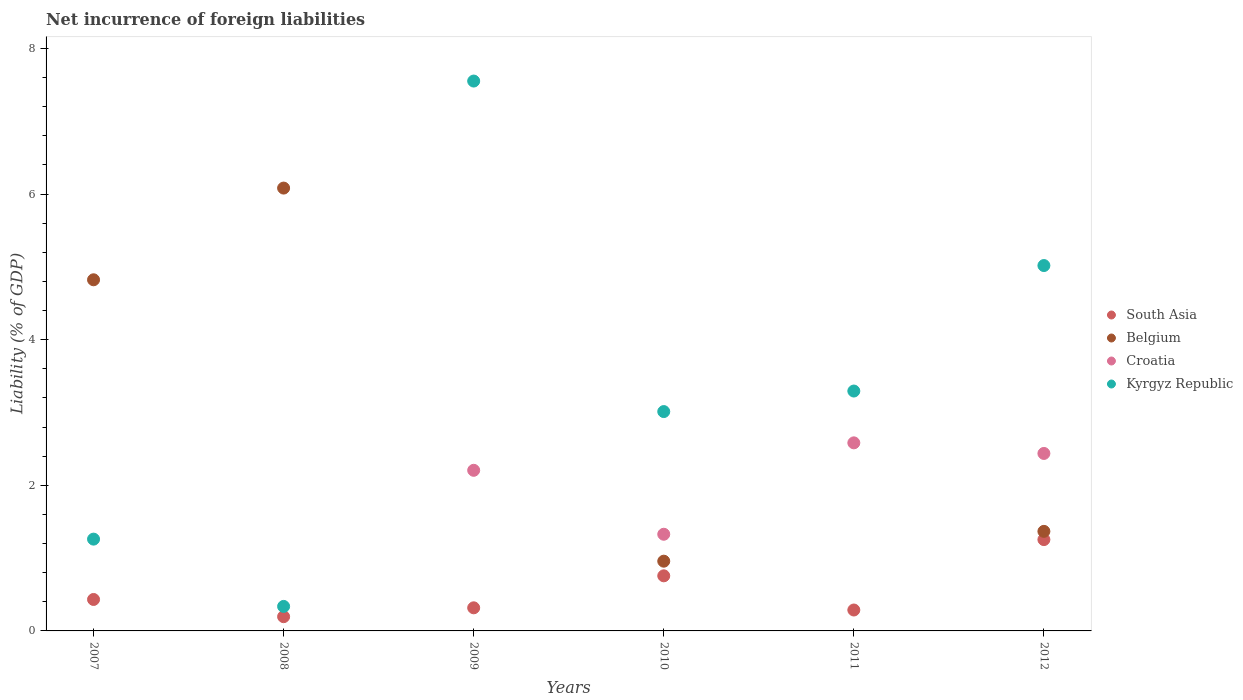How many different coloured dotlines are there?
Your answer should be very brief. 4. What is the net incurrence of foreign liabilities in Kyrgyz Republic in 2009?
Offer a very short reply. 7.55. Across all years, what is the maximum net incurrence of foreign liabilities in Croatia?
Your answer should be very brief. 2.58. Across all years, what is the minimum net incurrence of foreign liabilities in South Asia?
Provide a short and direct response. 0.2. In which year was the net incurrence of foreign liabilities in Kyrgyz Republic maximum?
Your response must be concise. 2009. What is the total net incurrence of foreign liabilities in Croatia in the graph?
Give a very brief answer. 8.56. What is the difference between the net incurrence of foreign liabilities in Croatia in 2011 and that in 2012?
Offer a very short reply. 0.15. What is the average net incurrence of foreign liabilities in South Asia per year?
Offer a very short reply. 0.54. In the year 2010, what is the difference between the net incurrence of foreign liabilities in Croatia and net incurrence of foreign liabilities in South Asia?
Give a very brief answer. 0.57. In how many years, is the net incurrence of foreign liabilities in Kyrgyz Republic greater than 7.6 %?
Make the answer very short. 0. What is the ratio of the net incurrence of foreign liabilities in Kyrgyz Republic in 2007 to that in 2010?
Your answer should be very brief. 0.42. What is the difference between the highest and the second highest net incurrence of foreign liabilities in Belgium?
Make the answer very short. 1.26. What is the difference between the highest and the lowest net incurrence of foreign liabilities in South Asia?
Keep it short and to the point. 1.06. Is the sum of the net incurrence of foreign liabilities in South Asia in 2007 and 2012 greater than the maximum net incurrence of foreign liabilities in Belgium across all years?
Provide a short and direct response. No. Is it the case that in every year, the sum of the net incurrence of foreign liabilities in Belgium and net incurrence of foreign liabilities in South Asia  is greater than the net incurrence of foreign liabilities in Kyrgyz Republic?
Offer a terse response. No. Is the net incurrence of foreign liabilities in Kyrgyz Republic strictly less than the net incurrence of foreign liabilities in Croatia over the years?
Ensure brevity in your answer.  No. What is the difference between two consecutive major ticks on the Y-axis?
Your answer should be compact. 2. Does the graph contain grids?
Your response must be concise. No. How many legend labels are there?
Offer a terse response. 4. What is the title of the graph?
Provide a short and direct response. Net incurrence of foreign liabilities. Does "Eritrea" appear as one of the legend labels in the graph?
Make the answer very short. No. What is the label or title of the X-axis?
Keep it short and to the point. Years. What is the label or title of the Y-axis?
Your answer should be very brief. Liability (% of GDP). What is the Liability (% of GDP) in South Asia in 2007?
Keep it short and to the point. 0.43. What is the Liability (% of GDP) of Belgium in 2007?
Your response must be concise. 4.82. What is the Liability (% of GDP) in Croatia in 2007?
Ensure brevity in your answer.  0. What is the Liability (% of GDP) of Kyrgyz Republic in 2007?
Ensure brevity in your answer.  1.26. What is the Liability (% of GDP) in South Asia in 2008?
Offer a very short reply. 0.2. What is the Liability (% of GDP) in Belgium in 2008?
Provide a short and direct response. 6.08. What is the Liability (% of GDP) in Croatia in 2008?
Provide a succinct answer. 0. What is the Liability (% of GDP) of Kyrgyz Republic in 2008?
Give a very brief answer. 0.34. What is the Liability (% of GDP) of South Asia in 2009?
Offer a terse response. 0.32. What is the Liability (% of GDP) of Belgium in 2009?
Offer a terse response. 0. What is the Liability (% of GDP) of Croatia in 2009?
Provide a short and direct response. 2.21. What is the Liability (% of GDP) in Kyrgyz Republic in 2009?
Give a very brief answer. 7.55. What is the Liability (% of GDP) in South Asia in 2010?
Make the answer very short. 0.76. What is the Liability (% of GDP) of Belgium in 2010?
Offer a very short reply. 0.96. What is the Liability (% of GDP) of Croatia in 2010?
Keep it short and to the point. 1.33. What is the Liability (% of GDP) of Kyrgyz Republic in 2010?
Ensure brevity in your answer.  3.01. What is the Liability (% of GDP) in South Asia in 2011?
Your answer should be very brief. 0.29. What is the Liability (% of GDP) in Belgium in 2011?
Provide a succinct answer. 0. What is the Liability (% of GDP) in Croatia in 2011?
Offer a terse response. 2.58. What is the Liability (% of GDP) of Kyrgyz Republic in 2011?
Offer a very short reply. 3.3. What is the Liability (% of GDP) in South Asia in 2012?
Your answer should be very brief. 1.25. What is the Liability (% of GDP) in Belgium in 2012?
Your answer should be compact. 1.37. What is the Liability (% of GDP) of Croatia in 2012?
Offer a terse response. 2.44. What is the Liability (% of GDP) in Kyrgyz Republic in 2012?
Your response must be concise. 5.02. Across all years, what is the maximum Liability (% of GDP) of South Asia?
Provide a short and direct response. 1.25. Across all years, what is the maximum Liability (% of GDP) of Belgium?
Offer a very short reply. 6.08. Across all years, what is the maximum Liability (% of GDP) of Croatia?
Offer a terse response. 2.58. Across all years, what is the maximum Liability (% of GDP) in Kyrgyz Republic?
Offer a terse response. 7.55. Across all years, what is the minimum Liability (% of GDP) of South Asia?
Your response must be concise. 0.2. Across all years, what is the minimum Liability (% of GDP) of Croatia?
Your response must be concise. 0. Across all years, what is the minimum Liability (% of GDP) in Kyrgyz Republic?
Your answer should be very brief. 0.34. What is the total Liability (% of GDP) of South Asia in the graph?
Keep it short and to the point. 3.24. What is the total Liability (% of GDP) in Belgium in the graph?
Your response must be concise. 13.23. What is the total Liability (% of GDP) of Croatia in the graph?
Your answer should be compact. 8.56. What is the total Liability (% of GDP) of Kyrgyz Republic in the graph?
Your answer should be compact. 20.48. What is the difference between the Liability (% of GDP) in South Asia in 2007 and that in 2008?
Offer a terse response. 0.24. What is the difference between the Liability (% of GDP) of Belgium in 2007 and that in 2008?
Provide a succinct answer. -1.26. What is the difference between the Liability (% of GDP) in Kyrgyz Republic in 2007 and that in 2008?
Your answer should be very brief. 0.92. What is the difference between the Liability (% of GDP) of South Asia in 2007 and that in 2009?
Keep it short and to the point. 0.11. What is the difference between the Liability (% of GDP) of Kyrgyz Republic in 2007 and that in 2009?
Keep it short and to the point. -6.29. What is the difference between the Liability (% of GDP) in South Asia in 2007 and that in 2010?
Make the answer very short. -0.32. What is the difference between the Liability (% of GDP) in Belgium in 2007 and that in 2010?
Give a very brief answer. 3.87. What is the difference between the Liability (% of GDP) in Kyrgyz Republic in 2007 and that in 2010?
Your answer should be compact. -1.75. What is the difference between the Liability (% of GDP) of South Asia in 2007 and that in 2011?
Provide a succinct answer. 0.14. What is the difference between the Liability (% of GDP) in Kyrgyz Republic in 2007 and that in 2011?
Keep it short and to the point. -2.03. What is the difference between the Liability (% of GDP) of South Asia in 2007 and that in 2012?
Keep it short and to the point. -0.82. What is the difference between the Liability (% of GDP) in Belgium in 2007 and that in 2012?
Offer a terse response. 3.46. What is the difference between the Liability (% of GDP) of Kyrgyz Republic in 2007 and that in 2012?
Ensure brevity in your answer.  -3.76. What is the difference between the Liability (% of GDP) in South Asia in 2008 and that in 2009?
Your answer should be compact. -0.12. What is the difference between the Liability (% of GDP) of Kyrgyz Republic in 2008 and that in 2009?
Ensure brevity in your answer.  -7.22. What is the difference between the Liability (% of GDP) of South Asia in 2008 and that in 2010?
Keep it short and to the point. -0.56. What is the difference between the Liability (% of GDP) of Belgium in 2008 and that in 2010?
Your answer should be compact. 5.12. What is the difference between the Liability (% of GDP) of Kyrgyz Republic in 2008 and that in 2010?
Your response must be concise. -2.68. What is the difference between the Liability (% of GDP) of South Asia in 2008 and that in 2011?
Your answer should be compact. -0.09. What is the difference between the Liability (% of GDP) of Kyrgyz Republic in 2008 and that in 2011?
Keep it short and to the point. -2.96. What is the difference between the Liability (% of GDP) of South Asia in 2008 and that in 2012?
Your response must be concise. -1.06. What is the difference between the Liability (% of GDP) of Belgium in 2008 and that in 2012?
Provide a succinct answer. 4.72. What is the difference between the Liability (% of GDP) of Kyrgyz Republic in 2008 and that in 2012?
Provide a succinct answer. -4.68. What is the difference between the Liability (% of GDP) of South Asia in 2009 and that in 2010?
Your answer should be compact. -0.44. What is the difference between the Liability (% of GDP) in Croatia in 2009 and that in 2010?
Give a very brief answer. 0.88. What is the difference between the Liability (% of GDP) in Kyrgyz Republic in 2009 and that in 2010?
Your response must be concise. 4.54. What is the difference between the Liability (% of GDP) of Croatia in 2009 and that in 2011?
Offer a terse response. -0.38. What is the difference between the Liability (% of GDP) in Kyrgyz Republic in 2009 and that in 2011?
Your answer should be compact. 4.26. What is the difference between the Liability (% of GDP) of South Asia in 2009 and that in 2012?
Keep it short and to the point. -0.94. What is the difference between the Liability (% of GDP) of Croatia in 2009 and that in 2012?
Make the answer very short. -0.23. What is the difference between the Liability (% of GDP) of Kyrgyz Republic in 2009 and that in 2012?
Keep it short and to the point. 2.53. What is the difference between the Liability (% of GDP) in South Asia in 2010 and that in 2011?
Your answer should be very brief. 0.47. What is the difference between the Liability (% of GDP) of Croatia in 2010 and that in 2011?
Offer a very short reply. -1.26. What is the difference between the Liability (% of GDP) of Kyrgyz Republic in 2010 and that in 2011?
Your answer should be compact. -0.28. What is the difference between the Liability (% of GDP) of South Asia in 2010 and that in 2012?
Make the answer very short. -0.5. What is the difference between the Liability (% of GDP) in Belgium in 2010 and that in 2012?
Your answer should be compact. -0.41. What is the difference between the Liability (% of GDP) in Croatia in 2010 and that in 2012?
Provide a succinct answer. -1.11. What is the difference between the Liability (% of GDP) in Kyrgyz Republic in 2010 and that in 2012?
Your response must be concise. -2.01. What is the difference between the Liability (% of GDP) of South Asia in 2011 and that in 2012?
Give a very brief answer. -0.97. What is the difference between the Liability (% of GDP) of Croatia in 2011 and that in 2012?
Make the answer very short. 0.15. What is the difference between the Liability (% of GDP) in Kyrgyz Republic in 2011 and that in 2012?
Provide a succinct answer. -1.72. What is the difference between the Liability (% of GDP) of South Asia in 2007 and the Liability (% of GDP) of Belgium in 2008?
Keep it short and to the point. -5.65. What is the difference between the Liability (% of GDP) in South Asia in 2007 and the Liability (% of GDP) in Kyrgyz Republic in 2008?
Provide a succinct answer. 0.1. What is the difference between the Liability (% of GDP) of Belgium in 2007 and the Liability (% of GDP) of Kyrgyz Republic in 2008?
Your answer should be very brief. 4.49. What is the difference between the Liability (% of GDP) in South Asia in 2007 and the Liability (% of GDP) in Croatia in 2009?
Your answer should be compact. -1.77. What is the difference between the Liability (% of GDP) of South Asia in 2007 and the Liability (% of GDP) of Kyrgyz Republic in 2009?
Provide a short and direct response. -7.12. What is the difference between the Liability (% of GDP) of Belgium in 2007 and the Liability (% of GDP) of Croatia in 2009?
Ensure brevity in your answer.  2.62. What is the difference between the Liability (% of GDP) in Belgium in 2007 and the Liability (% of GDP) in Kyrgyz Republic in 2009?
Provide a short and direct response. -2.73. What is the difference between the Liability (% of GDP) in South Asia in 2007 and the Liability (% of GDP) in Belgium in 2010?
Your answer should be compact. -0.53. What is the difference between the Liability (% of GDP) in South Asia in 2007 and the Liability (% of GDP) in Croatia in 2010?
Your answer should be compact. -0.9. What is the difference between the Liability (% of GDP) of South Asia in 2007 and the Liability (% of GDP) of Kyrgyz Republic in 2010?
Ensure brevity in your answer.  -2.58. What is the difference between the Liability (% of GDP) of Belgium in 2007 and the Liability (% of GDP) of Croatia in 2010?
Keep it short and to the point. 3.5. What is the difference between the Liability (% of GDP) in Belgium in 2007 and the Liability (% of GDP) in Kyrgyz Republic in 2010?
Provide a succinct answer. 1.81. What is the difference between the Liability (% of GDP) of South Asia in 2007 and the Liability (% of GDP) of Croatia in 2011?
Offer a terse response. -2.15. What is the difference between the Liability (% of GDP) in South Asia in 2007 and the Liability (% of GDP) in Kyrgyz Republic in 2011?
Your response must be concise. -2.86. What is the difference between the Liability (% of GDP) of Belgium in 2007 and the Liability (% of GDP) of Croatia in 2011?
Keep it short and to the point. 2.24. What is the difference between the Liability (% of GDP) in Belgium in 2007 and the Liability (% of GDP) in Kyrgyz Republic in 2011?
Your answer should be compact. 1.53. What is the difference between the Liability (% of GDP) in South Asia in 2007 and the Liability (% of GDP) in Belgium in 2012?
Give a very brief answer. -0.94. What is the difference between the Liability (% of GDP) in South Asia in 2007 and the Liability (% of GDP) in Croatia in 2012?
Keep it short and to the point. -2.01. What is the difference between the Liability (% of GDP) in South Asia in 2007 and the Liability (% of GDP) in Kyrgyz Republic in 2012?
Ensure brevity in your answer.  -4.59. What is the difference between the Liability (% of GDP) of Belgium in 2007 and the Liability (% of GDP) of Croatia in 2012?
Your answer should be compact. 2.39. What is the difference between the Liability (% of GDP) in Belgium in 2007 and the Liability (% of GDP) in Kyrgyz Republic in 2012?
Make the answer very short. -0.2. What is the difference between the Liability (% of GDP) of South Asia in 2008 and the Liability (% of GDP) of Croatia in 2009?
Ensure brevity in your answer.  -2.01. What is the difference between the Liability (% of GDP) in South Asia in 2008 and the Liability (% of GDP) in Kyrgyz Republic in 2009?
Give a very brief answer. -7.36. What is the difference between the Liability (% of GDP) of Belgium in 2008 and the Liability (% of GDP) of Croatia in 2009?
Offer a terse response. 3.88. What is the difference between the Liability (% of GDP) of Belgium in 2008 and the Liability (% of GDP) of Kyrgyz Republic in 2009?
Keep it short and to the point. -1.47. What is the difference between the Liability (% of GDP) in South Asia in 2008 and the Liability (% of GDP) in Belgium in 2010?
Offer a terse response. -0.76. What is the difference between the Liability (% of GDP) of South Asia in 2008 and the Liability (% of GDP) of Croatia in 2010?
Your response must be concise. -1.13. What is the difference between the Liability (% of GDP) of South Asia in 2008 and the Liability (% of GDP) of Kyrgyz Republic in 2010?
Provide a short and direct response. -2.82. What is the difference between the Liability (% of GDP) in Belgium in 2008 and the Liability (% of GDP) in Croatia in 2010?
Ensure brevity in your answer.  4.75. What is the difference between the Liability (% of GDP) in Belgium in 2008 and the Liability (% of GDP) in Kyrgyz Republic in 2010?
Your answer should be compact. 3.07. What is the difference between the Liability (% of GDP) of South Asia in 2008 and the Liability (% of GDP) of Croatia in 2011?
Your answer should be very brief. -2.39. What is the difference between the Liability (% of GDP) of South Asia in 2008 and the Liability (% of GDP) of Kyrgyz Republic in 2011?
Give a very brief answer. -3.1. What is the difference between the Liability (% of GDP) of Belgium in 2008 and the Liability (% of GDP) of Croatia in 2011?
Ensure brevity in your answer.  3.5. What is the difference between the Liability (% of GDP) in Belgium in 2008 and the Liability (% of GDP) in Kyrgyz Republic in 2011?
Keep it short and to the point. 2.79. What is the difference between the Liability (% of GDP) in South Asia in 2008 and the Liability (% of GDP) in Belgium in 2012?
Your answer should be compact. -1.17. What is the difference between the Liability (% of GDP) in South Asia in 2008 and the Liability (% of GDP) in Croatia in 2012?
Your answer should be compact. -2.24. What is the difference between the Liability (% of GDP) of South Asia in 2008 and the Liability (% of GDP) of Kyrgyz Republic in 2012?
Your answer should be compact. -4.82. What is the difference between the Liability (% of GDP) of Belgium in 2008 and the Liability (% of GDP) of Croatia in 2012?
Provide a short and direct response. 3.65. What is the difference between the Liability (% of GDP) of Belgium in 2008 and the Liability (% of GDP) of Kyrgyz Republic in 2012?
Provide a succinct answer. 1.06. What is the difference between the Liability (% of GDP) in South Asia in 2009 and the Liability (% of GDP) in Belgium in 2010?
Keep it short and to the point. -0.64. What is the difference between the Liability (% of GDP) in South Asia in 2009 and the Liability (% of GDP) in Croatia in 2010?
Keep it short and to the point. -1.01. What is the difference between the Liability (% of GDP) of South Asia in 2009 and the Liability (% of GDP) of Kyrgyz Republic in 2010?
Offer a very short reply. -2.7. What is the difference between the Liability (% of GDP) in Croatia in 2009 and the Liability (% of GDP) in Kyrgyz Republic in 2010?
Give a very brief answer. -0.81. What is the difference between the Liability (% of GDP) of South Asia in 2009 and the Liability (% of GDP) of Croatia in 2011?
Your answer should be compact. -2.27. What is the difference between the Liability (% of GDP) in South Asia in 2009 and the Liability (% of GDP) in Kyrgyz Republic in 2011?
Make the answer very short. -2.98. What is the difference between the Liability (% of GDP) in Croatia in 2009 and the Liability (% of GDP) in Kyrgyz Republic in 2011?
Ensure brevity in your answer.  -1.09. What is the difference between the Liability (% of GDP) in South Asia in 2009 and the Liability (% of GDP) in Belgium in 2012?
Your answer should be compact. -1.05. What is the difference between the Liability (% of GDP) of South Asia in 2009 and the Liability (% of GDP) of Croatia in 2012?
Offer a very short reply. -2.12. What is the difference between the Liability (% of GDP) in South Asia in 2009 and the Liability (% of GDP) in Kyrgyz Republic in 2012?
Make the answer very short. -4.7. What is the difference between the Liability (% of GDP) in Croatia in 2009 and the Liability (% of GDP) in Kyrgyz Republic in 2012?
Offer a very short reply. -2.81. What is the difference between the Liability (% of GDP) in South Asia in 2010 and the Liability (% of GDP) in Croatia in 2011?
Keep it short and to the point. -1.83. What is the difference between the Liability (% of GDP) of South Asia in 2010 and the Liability (% of GDP) of Kyrgyz Republic in 2011?
Keep it short and to the point. -2.54. What is the difference between the Liability (% of GDP) of Belgium in 2010 and the Liability (% of GDP) of Croatia in 2011?
Provide a succinct answer. -1.63. What is the difference between the Liability (% of GDP) in Belgium in 2010 and the Liability (% of GDP) in Kyrgyz Republic in 2011?
Your answer should be compact. -2.34. What is the difference between the Liability (% of GDP) of Croatia in 2010 and the Liability (% of GDP) of Kyrgyz Republic in 2011?
Offer a very short reply. -1.97. What is the difference between the Liability (% of GDP) in South Asia in 2010 and the Liability (% of GDP) in Belgium in 2012?
Ensure brevity in your answer.  -0.61. What is the difference between the Liability (% of GDP) in South Asia in 2010 and the Liability (% of GDP) in Croatia in 2012?
Provide a succinct answer. -1.68. What is the difference between the Liability (% of GDP) in South Asia in 2010 and the Liability (% of GDP) in Kyrgyz Republic in 2012?
Your answer should be compact. -4.26. What is the difference between the Liability (% of GDP) of Belgium in 2010 and the Liability (% of GDP) of Croatia in 2012?
Offer a very short reply. -1.48. What is the difference between the Liability (% of GDP) of Belgium in 2010 and the Liability (% of GDP) of Kyrgyz Republic in 2012?
Your answer should be very brief. -4.06. What is the difference between the Liability (% of GDP) in Croatia in 2010 and the Liability (% of GDP) in Kyrgyz Republic in 2012?
Ensure brevity in your answer.  -3.69. What is the difference between the Liability (% of GDP) in South Asia in 2011 and the Liability (% of GDP) in Belgium in 2012?
Offer a terse response. -1.08. What is the difference between the Liability (% of GDP) in South Asia in 2011 and the Liability (% of GDP) in Croatia in 2012?
Provide a succinct answer. -2.15. What is the difference between the Liability (% of GDP) of South Asia in 2011 and the Liability (% of GDP) of Kyrgyz Republic in 2012?
Your answer should be compact. -4.73. What is the difference between the Liability (% of GDP) of Croatia in 2011 and the Liability (% of GDP) of Kyrgyz Republic in 2012?
Make the answer very short. -2.44. What is the average Liability (% of GDP) of South Asia per year?
Your response must be concise. 0.54. What is the average Liability (% of GDP) in Belgium per year?
Keep it short and to the point. 2.21. What is the average Liability (% of GDP) in Croatia per year?
Keep it short and to the point. 1.43. What is the average Liability (% of GDP) in Kyrgyz Republic per year?
Offer a very short reply. 3.41. In the year 2007, what is the difference between the Liability (% of GDP) of South Asia and Liability (% of GDP) of Belgium?
Offer a terse response. -4.39. In the year 2007, what is the difference between the Liability (% of GDP) in South Asia and Liability (% of GDP) in Kyrgyz Republic?
Offer a very short reply. -0.83. In the year 2007, what is the difference between the Liability (% of GDP) in Belgium and Liability (% of GDP) in Kyrgyz Republic?
Your response must be concise. 3.56. In the year 2008, what is the difference between the Liability (% of GDP) of South Asia and Liability (% of GDP) of Belgium?
Your answer should be very brief. -5.89. In the year 2008, what is the difference between the Liability (% of GDP) in South Asia and Liability (% of GDP) in Kyrgyz Republic?
Your answer should be compact. -0.14. In the year 2008, what is the difference between the Liability (% of GDP) in Belgium and Liability (% of GDP) in Kyrgyz Republic?
Offer a terse response. 5.75. In the year 2009, what is the difference between the Liability (% of GDP) in South Asia and Liability (% of GDP) in Croatia?
Provide a short and direct response. -1.89. In the year 2009, what is the difference between the Liability (% of GDP) of South Asia and Liability (% of GDP) of Kyrgyz Republic?
Keep it short and to the point. -7.24. In the year 2009, what is the difference between the Liability (% of GDP) in Croatia and Liability (% of GDP) in Kyrgyz Republic?
Provide a succinct answer. -5.35. In the year 2010, what is the difference between the Liability (% of GDP) in South Asia and Liability (% of GDP) in Belgium?
Your answer should be compact. -0.2. In the year 2010, what is the difference between the Liability (% of GDP) in South Asia and Liability (% of GDP) in Croatia?
Provide a short and direct response. -0.57. In the year 2010, what is the difference between the Liability (% of GDP) of South Asia and Liability (% of GDP) of Kyrgyz Republic?
Offer a very short reply. -2.26. In the year 2010, what is the difference between the Liability (% of GDP) of Belgium and Liability (% of GDP) of Croatia?
Make the answer very short. -0.37. In the year 2010, what is the difference between the Liability (% of GDP) of Belgium and Liability (% of GDP) of Kyrgyz Republic?
Keep it short and to the point. -2.06. In the year 2010, what is the difference between the Liability (% of GDP) in Croatia and Liability (% of GDP) in Kyrgyz Republic?
Make the answer very short. -1.69. In the year 2011, what is the difference between the Liability (% of GDP) of South Asia and Liability (% of GDP) of Croatia?
Your answer should be compact. -2.3. In the year 2011, what is the difference between the Liability (% of GDP) in South Asia and Liability (% of GDP) in Kyrgyz Republic?
Provide a succinct answer. -3.01. In the year 2011, what is the difference between the Liability (% of GDP) of Croatia and Liability (% of GDP) of Kyrgyz Republic?
Ensure brevity in your answer.  -0.71. In the year 2012, what is the difference between the Liability (% of GDP) in South Asia and Liability (% of GDP) in Belgium?
Your answer should be compact. -0.11. In the year 2012, what is the difference between the Liability (% of GDP) in South Asia and Liability (% of GDP) in Croatia?
Provide a short and direct response. -1.18. In the year 2012, what is the difference between the Liability (% of GDP) in South Asia and Liability (% of GDP) in Kyrgyz Republic?
Offer a terse response. -3.76. In the year 2012, what is the difference between the Liability (% of GDP) in Belgium and Liability (% of GDP) in Croatia?
Provide a short and direct response. -1.07. In the year 2012, what is the difference between the Liability (% of GDP) in Belgium and Liability (% of GDP) in Kyrgyz Republic?
Your answer should be very brief. -3.65. In the year 2012, what is the difference between the Liability (% of GDP) of Croatia and Liability (% of GDP) of Kyrgyz Republic?
Your answer should be compact. -2.58. What is the ratio of the Liability (% of GDP) of South Asia in 2007 to that in 2008?
Ensure brevity in your answer.  2.21. What is the ratio of the Liability (% of GDP) of Belgium in 2007 to that in 2008?
Your answer should be compact. 0.79. What is the ratio of the Liability (% of GDP) in Kyrgyz Republic in 2007 to that in 2008?
Provide a succinct answer. 3.75. What is the ratio of the Liability (% of GDP) in South Asia in 2007 to that in 2009?
Make the answer very short. 1.36. What is the ratio of the Liability (% of GDP) of Kyrgyz Republic in 2007 to that in 2009?
Provide a short and direct response. 0.17. What is the ratio of the Liability (% of GDP) of South Asia in 2007 to that in 2010?
Offer a terse response. 0.57. What is the ratio of the Liability (% of GDP) in Belgium in 2007 to that in 2010?
Offer a terse response. 5.03. What is the ratio of the Liability (% of GDP) of Kyrgyz Republic in 2007 to that in 2010?
Offer a terse response. 0.42. What is the ratio of the Liability (% of GDP) of South Asia in 2007 to that in 2011?
Your response must be concise. 1.5. What is the ratio of the Liability (% of GDP) in Kyrgyz Republic in 2007 to that in 2011?
Your answer should be compact. 0.38. What is the ratio of the Liability (% of GDP) in South Asia in 2007 to that in 2012?
Keep it short and to the point. 0.34. What is the ratio of the Liability (% of GDP) in Belgium in 2007 to that in 2012?
Give a very brief answer. 3.53. What is the ratio of the Liability (% of GDP) of Kyrgyz Republic in 2007 to that in 2012?
Give a very brief answer. 0.25. What is the ratio of the Liability (% of GDP) of South Asia in 2008 to that in 2009?
Provide a short and direct response. 0.62. What is the ratio of the Liability (% of GDP) in Kyrgyz Republic in 2008 to that in 2009?
Keep it short and to the point. 0.04. What is the ratio of the Liability (% of GDP) in South Asia in 2008 to that in 2010?
Offer a terse response. 0.26. What is the ratio of the Liability (% of GDP) in Belgium in 2008 to that in 2010?
Ensure brevity in your answer.  6.35. What is the ratio of the Liability (% of GDP) in Kyrgyz Republic in 2008 to that in 2010?
Offer a very short reply. 0.11. What is the ratio of the Liability (% of GDP) in South Asia in 2008 to that in 2011?
Provide a short and direct response. 0.68. What is the ratio of the Liability (% of GDP) of Kyrgyz Republic in 2008 to that in 2011?
Your answer should be very brief. 0.1. What is the ratio of the Liability (% of GDP) of South Asia in 2008 to that in 2012?
Make the answer very short. 0.16. What is the ratio of the Liability (% of GDP) in Belgium in 2008 to that in 2012?
Ensure brevity in your answer.  4.45. What is the ratio of the Liability (% of GDP) of Kyrgyz Republic in 2008 to that in 2012?
Ensure brevity in your answer.  0.07. What is the ratio of the Liability (% of GDP) of South Asia in 2009 to that in 2010?
Ensure brevity in your answer.  0.42. What is the ratio of the Liability (% of GDP) in Croatia in 2009 to that in 2010?
Give a very brief answer. 1.66. What is the ratio of the Liability (% of GDP) of Kyrgyz Republic in 2009 to that in 2010?
Offer a terse response. 2.51. What is the ratio of the Liability (% of GDP) in South Asia in 2009 to that in 2011?
Give a very brief answer. 1.1. What is the ratio of the Liability (% of GDP) of Croatia in 2009 to that in 2011?
Make the answer very short. 0.85. What is the ratio of the Liability (% of GDP) of Kyrgyz Republic in 2009 to that in 2011?
Make the answer very short. 2.29. What is the ratio of the Liability (% of GDP) of South Asia in 2009 to that in 2012?
Your answer should be very brief. 0.25. What is the ratio of the Liability (% of GDP) in Croatia in 2009 to that in 2012?
Your answer should be compact. 0.91. What is the ratio of the Liability (% of GDP) of Kyrgyz Republic in 2009 to that in 2012?
Offer a terse response. 1.5. What is the ratio of the Liability (% of GDP) of South Asia in 2010 to that in 2011?
Keep it short and to the point. 2.63. What is the ratio of the Liability (% of GDP) of Croatia in 2010 to that in 2011?
Provide a short and direct response. 0.51. What is the ratio of the Liability (% of GDP) in Kyrgyz Republic in 2010 to that in 2011?
Your response must be concise. 0.91. What is the ratio of the Liability (% of GDP) in South Asia in 2010 to that in 2012?
Provide a succinct answer. 0.6. What is the ratio of the Liability (% of GDP) in Belgium in 2010 to that in 2012?
Your answer should be compact. 0.7. What is the ratio of the Liability (% of GDP) in Croatia in 2010 to that in 2012?
Provide a succinct answer. 0.54. What is the ratio of the Liability (% of GDP) in Kyrgyz Republic in 2010 to that in 2012?
Provide a succinct answer. 0.6. What is the ratio of the Liability (% of GDP) of South Asia in 2011 to that in 2012?
Provide a succinct answer. 0.23. What is the ratio of the Liability (% of GDP) of Croatia in 2011 to that in 2012?
Offer a terse response. 1.06. What is the ratio of the Liability (% of GDP) in Kyrgyz Republic in 2011 to that in 2012?
Your response must be concise. 0.66. What is the difference between the highest and the second highest Liability (% of GDP) in South Asia?
Give a very brief answer. 0.5. What is the difference between the highest and the second highest Liability (% of GDP) of Belgium?
Your answer should be compact. 1.26. What is the difference between the highest and the second highest Liability (% of GDP) of Croatia?
Provide a succinct answer. 0.15. What is the difference between the highest and the second highest Liability (% of GDP) of Kyrgyz Republic?
Offer a terse response. 2.53. What is the difference between the highest and the lowest Liability (% of GDP) of South Asia?
Provide a succinct answer. 1.06. What is the difference between the highest and the lowest Liability (% of GDP) of Belgium?
Ensure brevity in your answer.  6.08. What is the difference between the highest and the lowest Liability (% of GDP) in Croatia?
Ensure brevity in your answer.  2.58. What is the difference between the highest and the lowest Liability (% of GDP) in Kyrgyz Republic?
Offer a terse response. 7.22. 